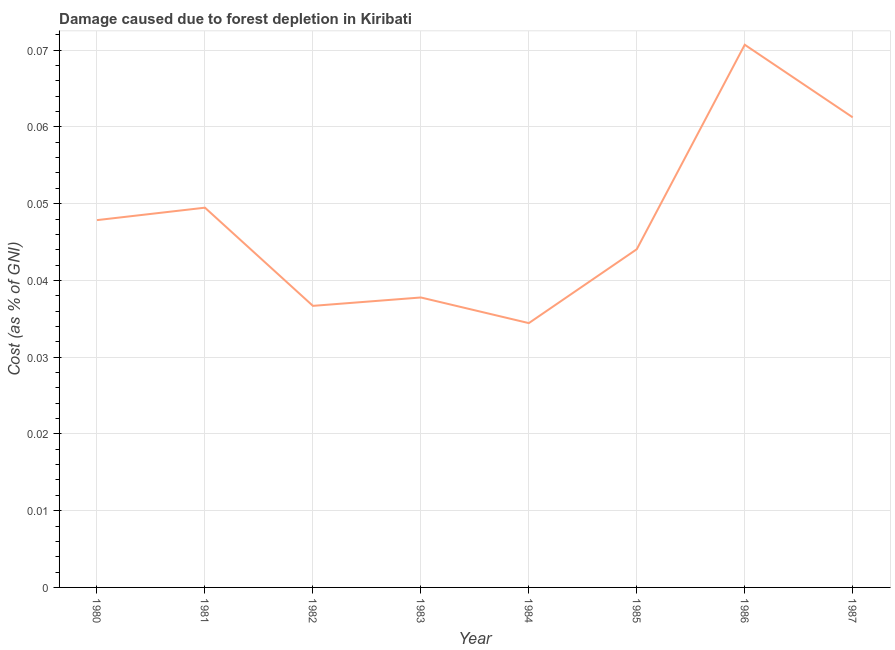What is the damage caused due to forest depletion in 1987?
Ensure brevity in your answer.  0.06. Across all years, what is the maximum damage caused due to forest depletion?
Your answer should be compact. 0.07. Across all years, what is the minimum damage caused due to forest depletion?
Your answer should be very brief. 0.03. In which year was the damage caused due to forest depletion maximum?
Provide a short and direct response. 1986. What is the sum of the damage caused due to forest depletion?
Your answer should be compact. 0.38. What is the difference between the damage caused due to forest depletion in 1982 and 1987?
Ensure brevity in your answer.  -0.02. What is the average damage caused due to forest depletion per year?
Your answer should be very brief. 0.05. What is the median damage caused due to forest depletion?
Give a very brief answer. 0.05. What is the ratio of the damage caused due to forest depletion in 1980 to that in 1986?
Make the answer very short. 0.68. Is the difference between the damage caused due to forest depletion in 1980 and 1981 greater than the difference between any two years?
Make the answer very short. No. What is the difference between the highest and the second highest damage caused due to forest depletion?
Your answer should be very brief. 0.01. Is the sum of the damage caused due to forest depletion in 1983 and 1984 greater than the maximum damage caused due to forest depletion across all years?
Ensure brevity in your answer.  Yes. What is the difference between the highest and the lowest damage caused due to forest depletion?
Offer a very short reply. 0.04. In how many years, is the damage caused due to forest depletion greater than the average damage caused due to forest depletion taken over all years?
Offer a very short reply. 4. How many years are there in the graph?
Offer a terse response. 8. What is the difference between two consecutive major ticks on the Y-axis?
Your answer should be compact. 0.01. Are the values on the major ticks of Y-axis written in scientific E-notation?
Your response must be concise. No. Does the graph contain grids?
Offer a terse response. Yes. What is the title of the graph?
Make the answer very short. Damage caused due to forest depletion in Kiribati. What is the label or title of the X-axis?
Keep it short and to the point. Year. What is the label or title of the Y-axis?
Provide a succinct answer. Cost (as % of GNI). What is the Cost (as % of GNI) of 1980?
Your response must be concise. 0.05. What is the Cost (as % of GNI) in 1981?
Offer a very short reply. 0.05. What is the Cost (as % of GNI) of 1982?
Provide a succinct answer. 0.04. What is the Cost (as % of GNI) in 1983?
Keep it short and to the point. 0.04. What is the Cost (as % of GNI) of 1984?
Keep it short and to the point. 0.03. What is the Cost (as % of GNI) in 1985?
Keep it short and to the point. 0.04. What is the Cost (as % of GNI) of 1986?
Ensure brevity in your answer.  0.07. What is the Cost (as % of GNI) in 1987?
Your answer should be compact. 0.06. What is the difference between the Cost (as % of GNI) in 1980 and 1981?
Offer a terse response. -0. What is the difference between the Cost (as % of GNI) in 1980 and 1982?
Your response must be concise. 0.01. What is the difference between the Cost (as % of GNI) in 1980 and 1983?
Your answer should be compact. 0.01. What is the difference between the Cost (as % of GNI) in 1980 and 1984?
Offer a very short reply. 0.01. What is the difference between the Cost (as % of GNI) in 1980 and 1985?
Ensure brevity in your answer.  0. What is the difference between the Cost (as % of GNI) in 1980 and 1986?
Provide a short and direct response. -0.02. What is the difference between the Cost (as % of GNI) in 1980 and 1987?
Make the answer very short. -0.01. What is the difference between the Cost (as % of GNI) in 1981 and 1982?
Your answer should be compact. 0.01. What is the difference between the Cost (as % of GNI) in 1981 and 1983?
Give a very brief answer. 0.01. What is the difference between the Cost (as % of GNI) in 1981 and 1984?
Your answer should be compact. 0.02. What is the difference between the Cost (as % of GNI) in 1981 and 1985?
Ensure brevity in your answer.  0.01. What is the difference between the Cost (as % of GNI) in 1981 and 1986?
Give a very brief answer. -0.02. What is the difference between the Cost (as % of GNI) in 1981 and 1987?
Keep it short and to the point. -0.01. What is the difference between the Cost (as % of GNI) in 1982 and 1983?
Offer a very short reply. -0. What is the difference between the Cost (as % of GNI) in 1982 and 1984?
Your answer should be very brief. 0. What is the difference between the Cost (as % of GNI) in 1982 and 1985?
Offer a terse response. -0.01. What is the difference between the Cost (as % of GNI) in 1982 and 1986?
Your answer should be very brief. -0.03. What is the difference between the Cost (as % of GNI) in 1982 and 1987?
Your answer should be compact. -0.02. What is the difference between the Cost (as % of GNI) in 1983 and 1984?
Keep it short and to the point. 0. What is the difference between the Cost (as % of GNI) in 1983 and 1985?
Offer a very short reply. -0.01. What is the difference between the Cost (as % of GNI) in 1983 and 1986?
Make the answer very short. -0.03. What is the difference between the Cost (as % of GNI) in 1983 and 1987?
Your response must be concise. -0.02. What is the difference between the Cost (as % of GNI) in 1984 and 1985?
Give a very brief answer. -0.01. What is the difference between the Cost (as % of GNI) in 1984 and 1986?
Your answer should be compact. -0.04. What is the difference between the Cost (as % of GNI) in 1984 and 1987?
Offer a very short reply. -0.03. What is the difference between the Cost (as % of GNI) in 1985 and 1986?
Your answer should be compact. -0.03. What is the difference between the Cost (as % of GNI) in 1985 and 1987?
Offer a very short reply. -0.02. What is the difference between the Cost (as % of GNI) in 1986 and 1987?
Your answer should be very brief. 0.01. What is the ratio of the Cost (as % of GNI) in 1980 to that in 1982?
Offer a very short reply. 1.3. What is the ratio of the Cost (as % of GNI) in 1980 to that in 1983?
Provide a succinct answer. 1.27. What is the ratio of the Cost (as % of GNI) in 1980 to that in 1984?
Your answer should be compact. 1.39. What is the ratio of the Cost (as % of GNI) in 1980 to that in 1985?
Your answer should be compact. 1.09. What is the ratio of the Cost (as % of GNI) in 1980 to that in 1986?
Provide a short and direct response. 0.68. What is the ratio of the Cost (as % of GNI) in 1980 to that in 1987?
Keep it short and to the point. 0.78. What is the ratio of the Cost (as % of GNI) in 1981 to that in 1982?
Your response must be concise. 1.35. What is the ratio of the Cost (as % of GNI) in 1981 to that in 1983?
Ensure brevity in your answer.  1.31. What is the ratio of the Cost (as % of GNI) in 1981 to that in 1984?
Provide a succinct answer. 1.44. What is the ratio of the Cost (as % of GNI) in 1981 to that in 1985?
Provide a succinct answer. 1.12. What is the ratio of the Cost (as % of GNI) in 1981 to that in 1986?
Your answer should be compact. 0.7. What is the ratio of the Cost (as % of GNI) in 1981 to that in 1987?
Your answer should be very brief. 0.81. What is the ratio of the Cost (as % of GNI) in 1982 to that in 1984?
Offer a very short reply. 1.06. What is the ratio of the Cost (as % of GNI) in 1982 to that in 1985?
Make the answer very short. 0.83. What is the ratio of the Cost (as % of GNI) in 1982 to that in 1986?
Offer a terse response. 0.52. What is the ratio of the Cost (as % of GNI) in 1982 to that in 1987?
Keep it short and to the point. 0.6. What is the ratio of the Cost (as % of GNI) in 1983 to that in 1984?
Your answer should be very brief. 1.1. What is the ratio of the Cost (as % of GNI) in 1983 to that in 1985?
Provide a succinct answer. 0.86. What is the ratio of the Cost (as % of GNI) in 1983 to that in 1986?
Make the answer very short. 0.53. What is the ratio of the Cost (as % of GNI) in 1983 to that in 1987?
Offer a terse response. 0.62. What is the ratio of the Cost (as % of GNI) in 1984 to that in 1985?
Provide a short and direct response. 0.78. What is the ratio of the Cost (as % of GNI) in 1984 to that in 1986?
Provide a short and direct response. 0.49. What is the ratio of the Cost (as % of GNI) in 1984 to that in 1987?
Keep it short and to the point. 0.56. What is the ratio of the Cost (as % of GNI) in 1985 to that in 1986?
Make the answer very short. 0.62. What is the ratio of the Cost (as % of GNI) in 1985 to that in 1987?
Give a very brief answer. 0.72. What is the ratio of the Cost (as % of GNI) in 1986 to that in 1987?
Give a very brief answer. 1.15. 